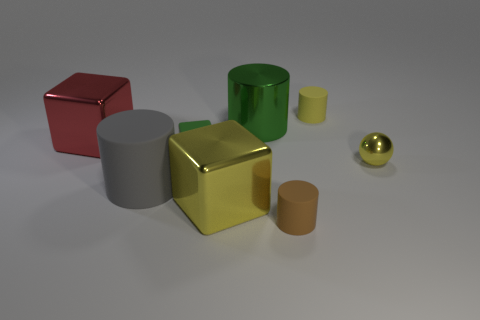There is a big green thing that is the same shape as the large gray object; what is its material?
Offer a very short reply. Metal. What number of other things are there of the same shape as the large red thing?
Your answer should be very brief. 2. There is a small cube in front of the large cylinder on the right side of the small matte block; how many large gray cylinders are right of it?
Provide a short and direct response. 0. How many tiny green rubber things have the same shape as the big matte thing?
Offer a very short reply. 0. There is a shiny block in front of the large gray matte object; is its color the same as the tiny metallic sphere?
Offer a terse response. Yes. There is a large shiny thing that is to the left of the yellow object that is on the left side of the tiny matte cylinder that is behind the shiny sphere; what shape is it?
Provide a short and direct response. Cube. Does the green rubber thing have the same size as the cylinder in front of the big gray object?
Keep it short and to the point. Yes. Are there any red shiny balls that have the same size as the yellow cylinder?
Provide a succinct answer. No. What number of other objects are the same material as the yellow block?
Offer a terse response. 3. What is the color of the big metal thing that is to the right of the red metal cube and in front of the large shiny cylinder?
Your answer should be compact. Yellow. 